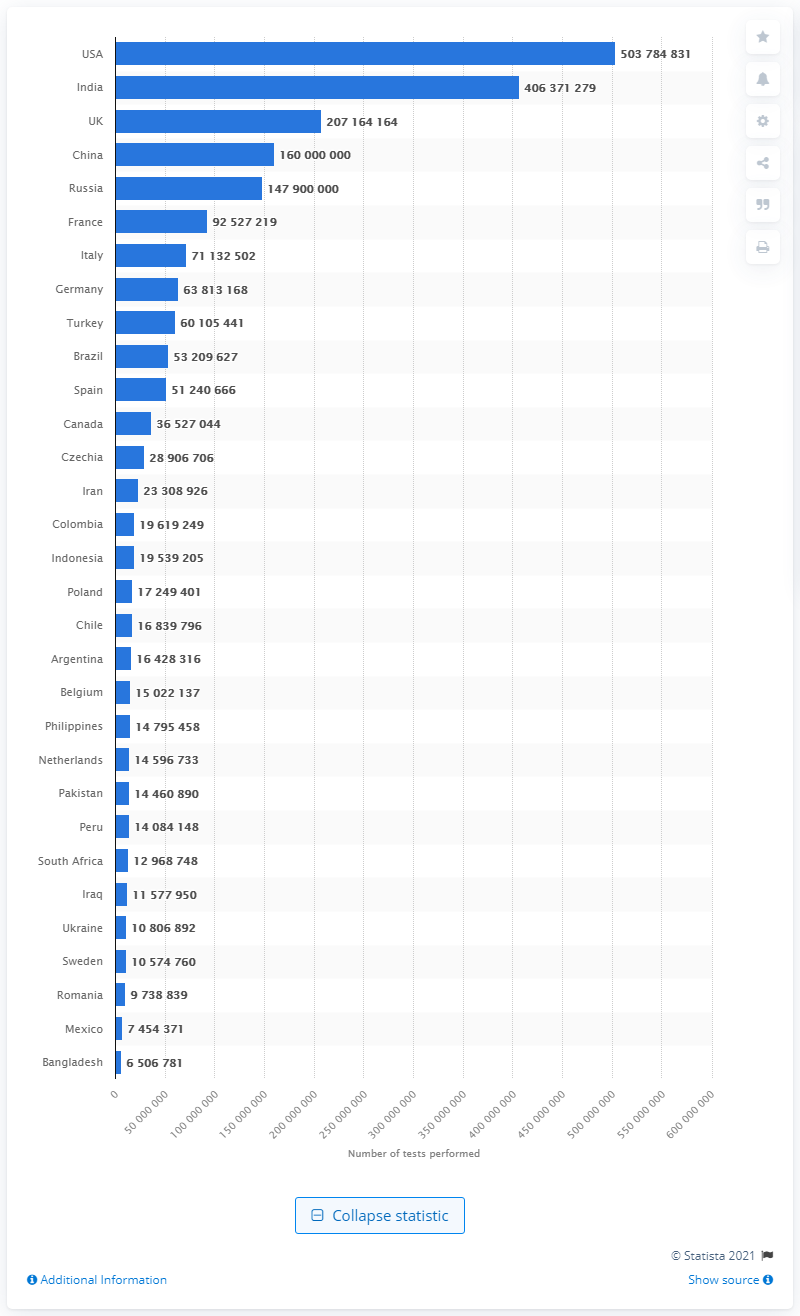Highlight a few significant elements in this photo. As of June 28, 2021, the United States had performed a total of 503,784,831 COVID-19 tests. Russia has conducted over 147 million COVID-19 tests. 